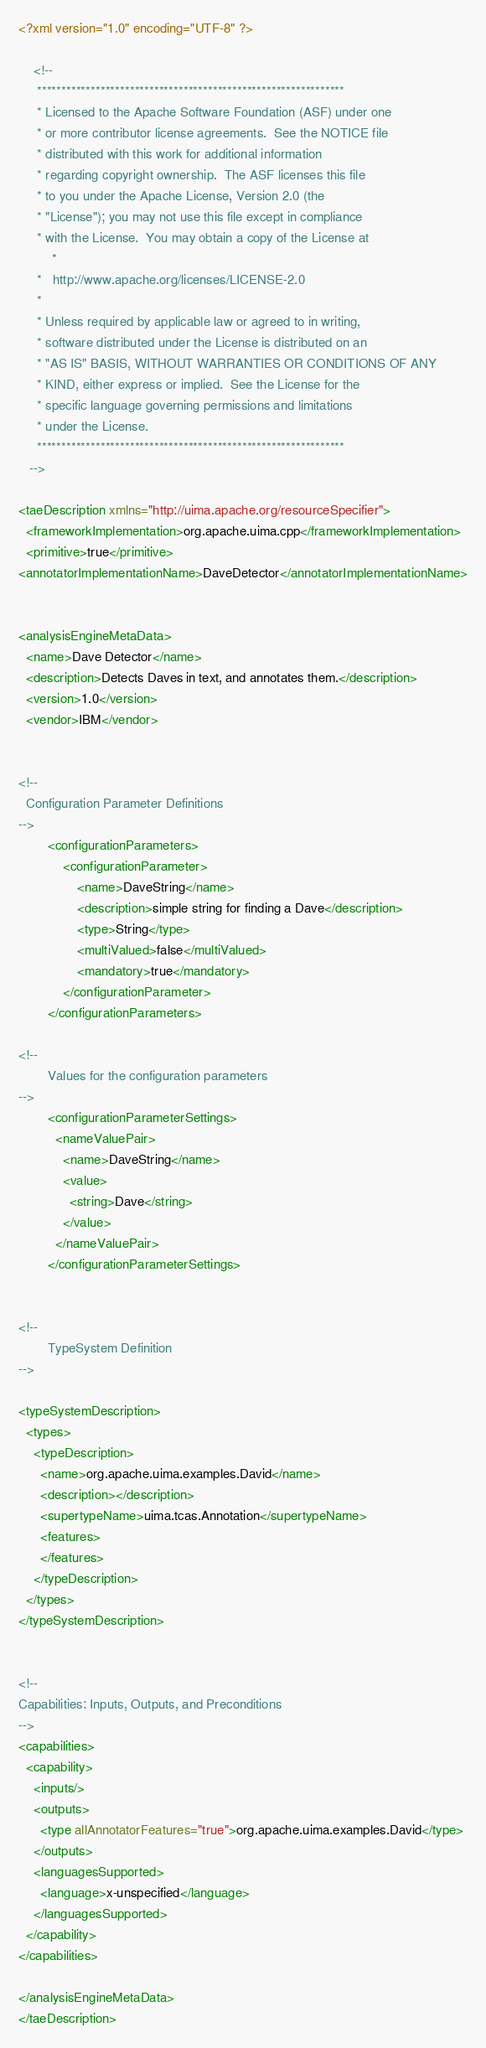<code> <loc_0><loc_0><loc_500><loc_500><_XML_><?xml version="1.0" encoding="UTF-8" ?> 

	<!--
	 ***************************************************************
	 * Licensed to the Apache Software Foundation (ASF) under one
	 * or more contributor license agreements.  See the NOTICE file
	 * distributed with this work for additional information
	 * regarding copyright ownership.  The ASF licenses this file
	 * to you under the Apache License, Version 2.0 (the
	 * "License"); you may not use this file except in compliance
	 * with the License.  You may obtain a copy of the License at
         *
	 *   http://www.apache.org/licenses/LICENSE-2.0
	 * 
	 * Unless required by applicable law or agreed to in writing,
	 * software distributed under the License is distributed on an
	 * "AS IS" BASIS, WITHOUT WARRANTIES OR CONDITIONS OF ANY
	 * KIND, either express or implied.  See the License for the
	 * specific language governing permissions and limitations
	 * under the License.
	 ***************************************************************
   -->

<taeDescription xmlns="http://uima.apache.org/resourceSpecifier">
  <frameworkImplementation>org.apache.uima.cpp</frameworkImplementation>
  <primitive>true</primitive>
<annotatorImplementationName>DaveDetector</annotatorImplementationName>


<analysisEngineMetaData>
  <name>Dave Detector</name>
  <description>Detects Daves in text, and annotates them.</description>
  <version>1.0</version>
  <vendor>IBM</vendor>


<!--
  Configuration Parameter Definitions
-->
        <configurationParameters>
            <configurationParameter>
                <name>DaveString</name>
                <description>simple string for finding a Dave</description>
                <type>String</type>
                <multiValued>false</multiValued>
                <mandatory>true</mandatory>
            </configurationParameter>
        </configurationParameters>

<!--
        Values for the configuration parameters
-->
        <configurationParameterSettings>
          <nameValuePair>
            <name>DaveString</name>
            <value>
              <string>Dave</string>
            </value>
          </nameValuePair>
        </configurationParameterSettings>
 

<!--
        TypeSystem Definition
-->

<typeSystemDescription>
  <types>
    <typeDescription>
      <name>org.apache.uima.examples.David</name>
      <description></description>
      <supertypeName>uima.tcas.Annotation</supertypeName>
      <features>
      </features>
    </typeDescription>
  </types>
</typeSystemDescription>


<!--
Capabilities: Inputs, Outputs, and Preconditions
-->
<capabilities>
  <capability>
    <inputs/>
    <outputs>
      <type allAnnotatorFeatures="true">org.apache.uima.examples.David</type>
    </outputs> 
    <languagesSupported>
      <language>x-unspecified</language>
    </languagesSupported>
  </capability>
</capabilities>

</analysisEngineMetaData>
</taeDescription>

</code> 